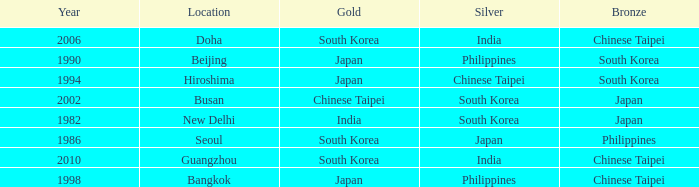Which Year is the highest one that has a Bronze of south korea, and a Silver of philippines? 1990.0. 